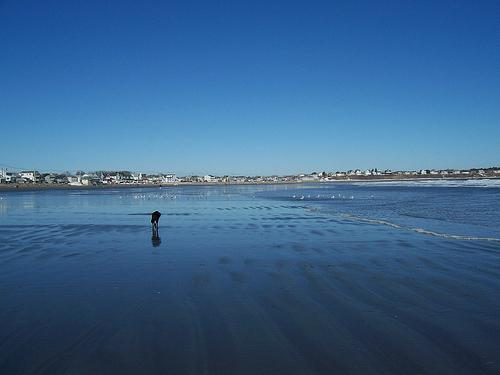Question: where is the water located in this photo?
Choices:
A. The left.
B. Behind the barn.
C. The right side.
D. Under the boat.
Answer with the letter. Answer: C Question: what is the main color of the houses in the background?
Choices:
A. Brown.
B. Red.
C. White.
D. Black.
Answer with the letter. Answer: C Question: what type of ground has ripples in this photo?
Choices:
A. Water.
B. Sand.
C. Snow.
D. Grass.
Answer with the letter. Answer: B Question: what color are the birds in the water?
Choices:
A. Black.
B. Brown.
C. White.
D. Gray.
Answer with the letter. Answer: C Question: what is the tide level based on this photo?
Choices:
A. High tide.
B. Medium tide.
C. Surfers tide.
D. Low tide.
Answer with the letter. Answer: D 